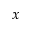Convert formula to latex. <formula><loc_0><loc_0><loc_500><loc_500>x</formula> 